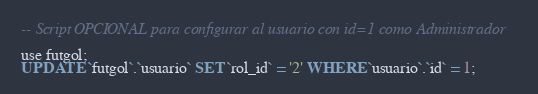<code> <loc_0><loc_0><loc_500><loc_500><_SQL_>-- Script OPCIONAL para configurar al usuario con id=1 como Administrador

use futgol;
UPDATE `futgol`.`usuario` SET `rol_id` = '2' WHERE `usuario`.`id` = 1;</code> 